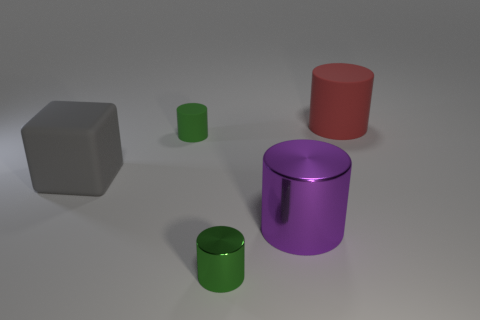Subtract all large red matte cylinders. How many cylinders are left? 3 Subtract all large things. Subtract all purple metallic things. How many objects are left? 1 Add 4 big metallic cylinders. How many big metallic cylinders are left? 5 Add 1 tiny green cylinders. How many tiny green cylinders exist? 3 Add 5 purple rubber cylinders. How many objects exist? 10 Subtract all purple cylinders. How many cylinders are left? 3 Subtract 0 yellow balls. How many objects are left? 5 Subtract all cubes. How many objects are left? 4 Subtract 1 cylinders. How many cylinders are left? 3 Subtract all brown blocks. Subtract all blue cylinders. How many blocks are left? 1 